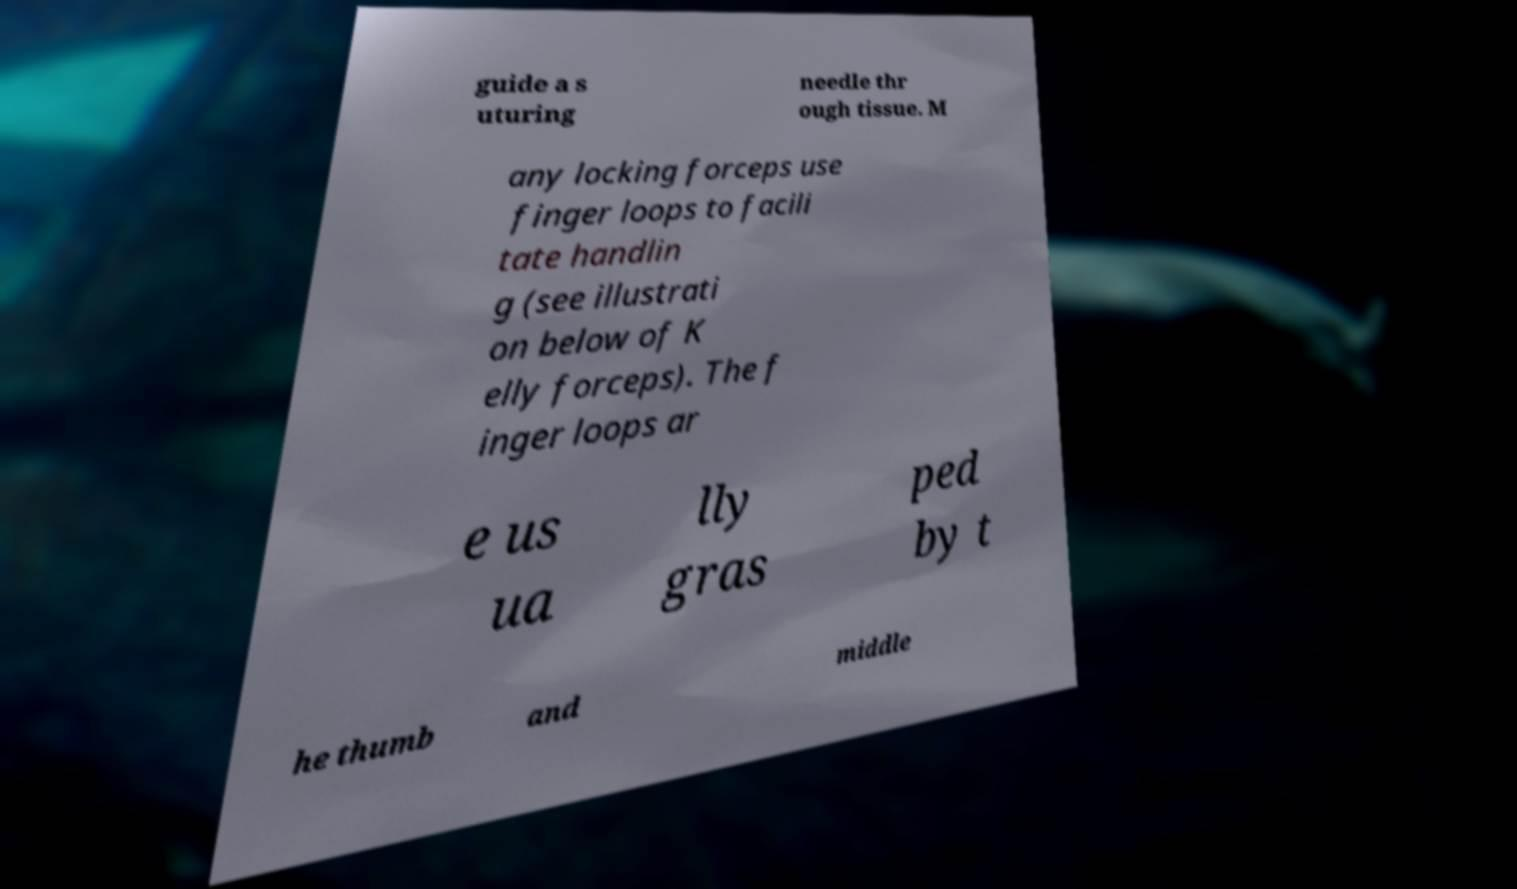Can you read and provide the text displayed in the image?This photo seems to have some interesting text. Can you extract and type it out for me? guide a s uturing needle thr ough tissue. M any locking forceps use finger loops to facili tate handlin g (see illustrati on below of K elly forceps). The f inger loops ar e us ua lly gras ped by t he thumb and middle 